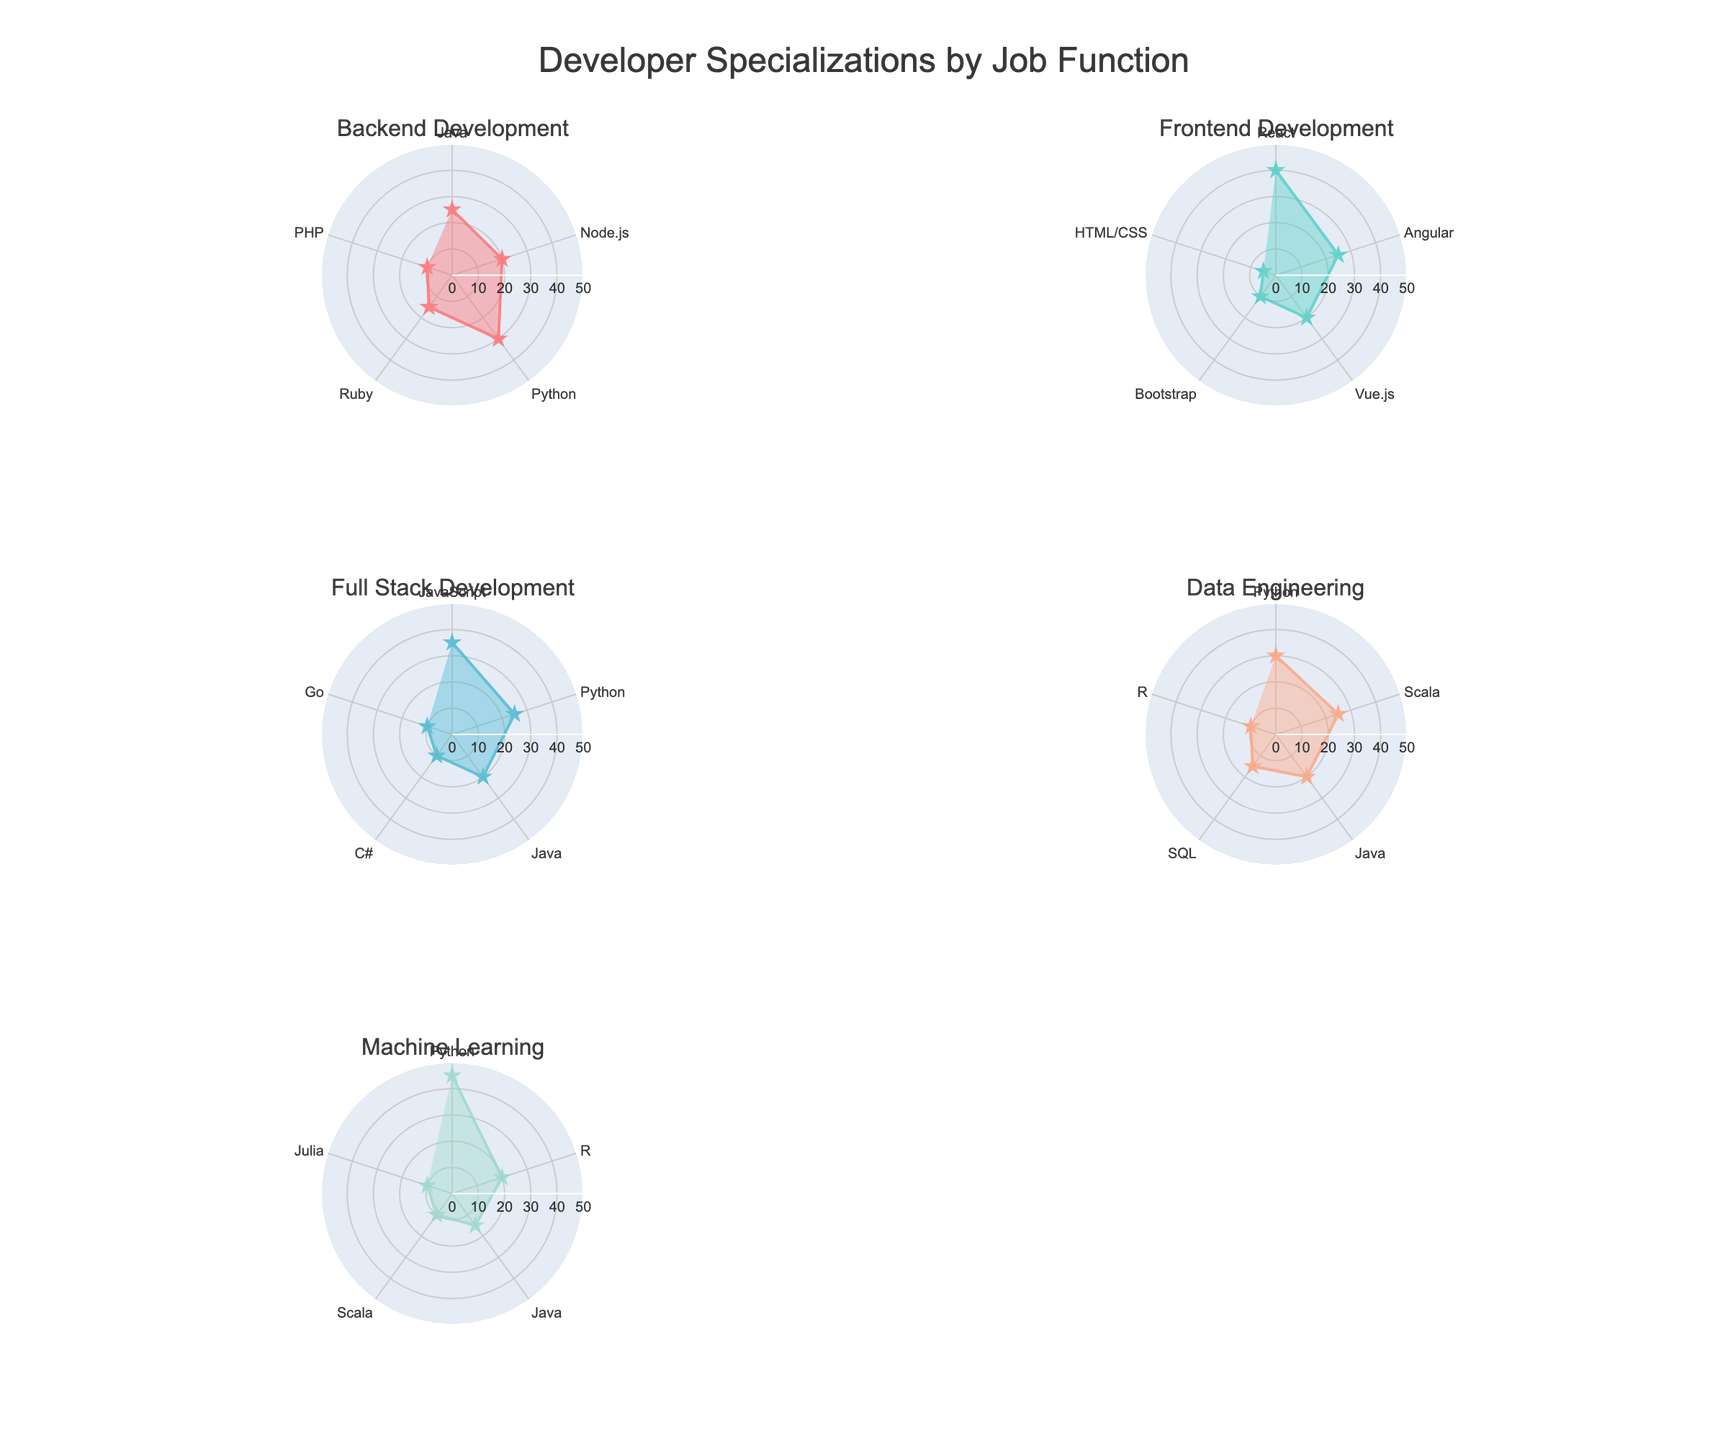What's the title of the subplot figure? The title is prominently displayed above the figure, which provides context about what the figure is depicting. In this case, "Developer Specializations by Job Function" is the title given to summarize what the entire figure shows.
Answer: Developer Specializations by Job Function How many job functions are represented in the figure? Each subplot represents a different job function. By counting the titles of each subplot, we can see there are five such titles, corresponding to five job functions.
Answer: Five Which developer specialization has the highest percentage in Backend Development? In the Backend Development subplot, by observing the lengths of the radial lines, Python extends the furthest, indicating it has the highest percentage.
Answer: Python What is the total percentage for Frontend Development specializations? To find the total percentage for Frontend Development, sum the percentages of all specializations within that subplot: 40 (React) + 25 (Angular) + 20 (Vue.js) + 10 (Bootstrap) + 5 (HTML/CSS). The total is 100%.
Answer: 100% How does the maximum percentage for Machine Learning compare to the maximum percentage for Data Engineering? In the Machine Learning subplot, Python has the highest percentage at 45%. In the Data Engineering subplot, Python also has the highest percentage but at 30%. Thus, Machine Learning's maximum percentage (45%) is higher than that of Data Engineering (30%).
Answer: Machine Learning's maximum is higher What is the average percentage for Full Stack Development specializations? Calculate the average by summing the percentages of all specializations for Full Stack Development and then dividing by the number of specializations: (35 + 25 + 20 + 10 + 10)/5 = 20%.
Answer: 20% Which job function has the specialization with the highest individual percentage across all job functions? By comparing the highest values from all subplots: Backend Development (Python at 30%), Frontend Development (React at 40%), Full Stack Development (JavaScript at 35%), Data Engineering (Python at 30%), and Machine Learning (Python at 45%), we see that Machine Learning has the highest individual percentage with Python at 45%.
Answer: Machine Learning For Data Engineering, which specialization has the smallest percentage? In the Data Engineering subplot, R is the specialization with the smallest percentage, as indicated by the shortest radial line at 10%.
Answer: R If we combine Backend and Full Stack Development, what is the combined percentage for Python? Backend Development has Python at 30%. Full Stack Development has Python at 25%. The combined percentage is 30% + 25% = 55%.
Answer: 55% Which job function has the most diverse set of specializations (i.e., the most number of different specializations represented)? Each subplot shows a different number of specializations. By counting these in each subplot, Full Stack Development and Data Engineering each display five different specializations, indicating they are the most diverse.
Answer: Full Stack Development and Data Engineering 